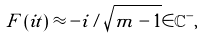<formula> <loc_0><loc_0><loc_500><loc_500>F \left ( i t \right ) \approx - i / \sqrt { m - 1 } \in \mathbb { C } ^ { - } ,</formula> 